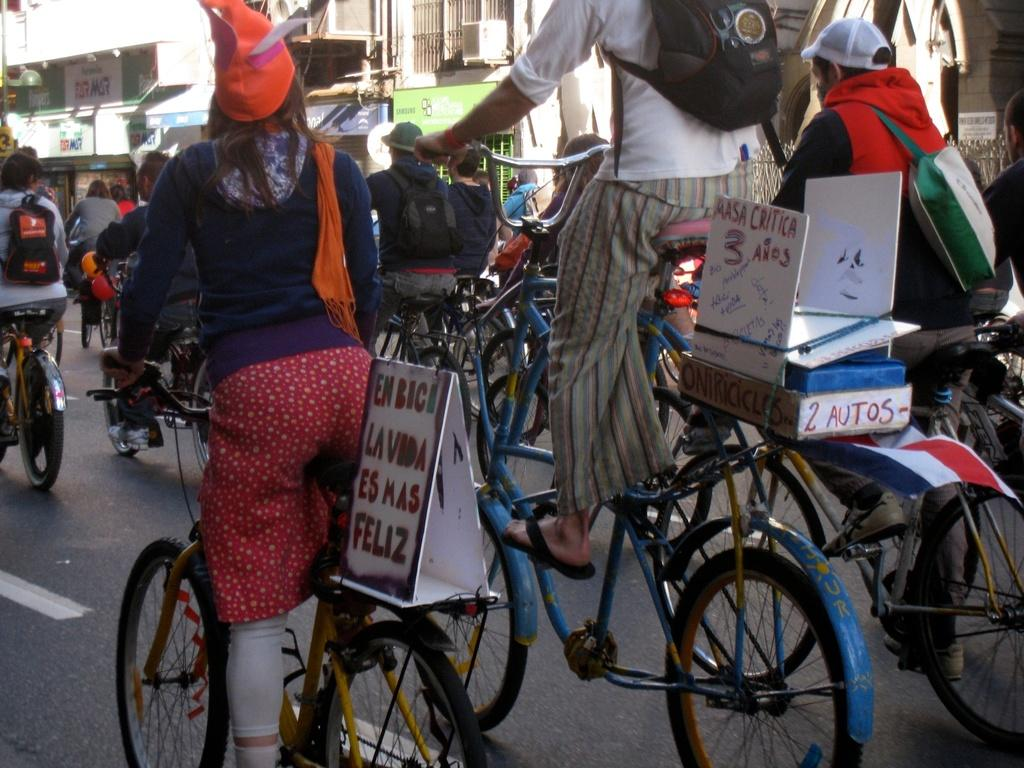What are the people in the image doing? The people in the image are riding cycles. What can be seen behind the cycles? There are boards visible behind the cycles. How much destruction can be seen in the image? There is no destruction present in the image; it features people riding cycles with boards in the background. 